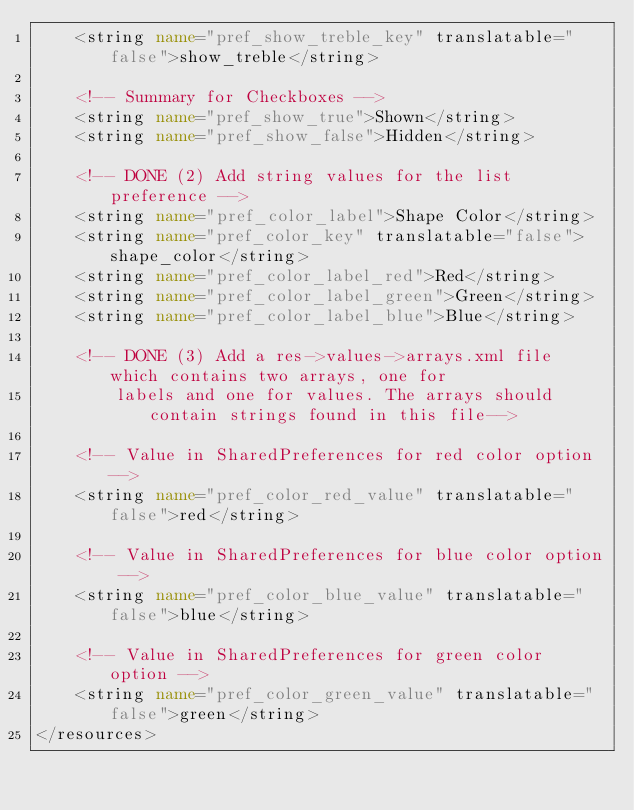Convert code to text. <code><loc_0><loc_0><loc_500><loc_500><_XML_>    <string name="pref_show_treble_key" translatable="false">show_treble</string>

    <!-- Summary for Checkboxes -->
    <string name="pref_show_true">Shown</string>
    <string name="pref_show_false">Hidden</string>

    <!-- DONE (2) Add string values for the list preference -->
    <string name="pref_color_label">Shape Color</string>
    <string name="pref_color_key" translatable="false">shape_color</string>
    <string name="pref_color_label_red">Red</string>
    <string name="pref_color_label_green">Green</string>
    <string name="pref_color_label_blue">Blue</string>

    <!-- DONE (3) Add a res->values->arrays.xml file which contains two arrays, one for
        labels and one for values. The arrays should contain strings found in this file-->

    <!-- Value in SharedPreferences for red color option -->
    <string name="pref_color_red_value" translatable="false">red</string>

    <!-- Value in SharedPreferences for blue color option -->
    <string name="pref_color_blue_value" translatable="false">blue</string>

    <!-- Value in SharedPreferences for green color option -->
    <string name="pref_color_green_value" translatable="false">green</string>
</resources>
</code> 